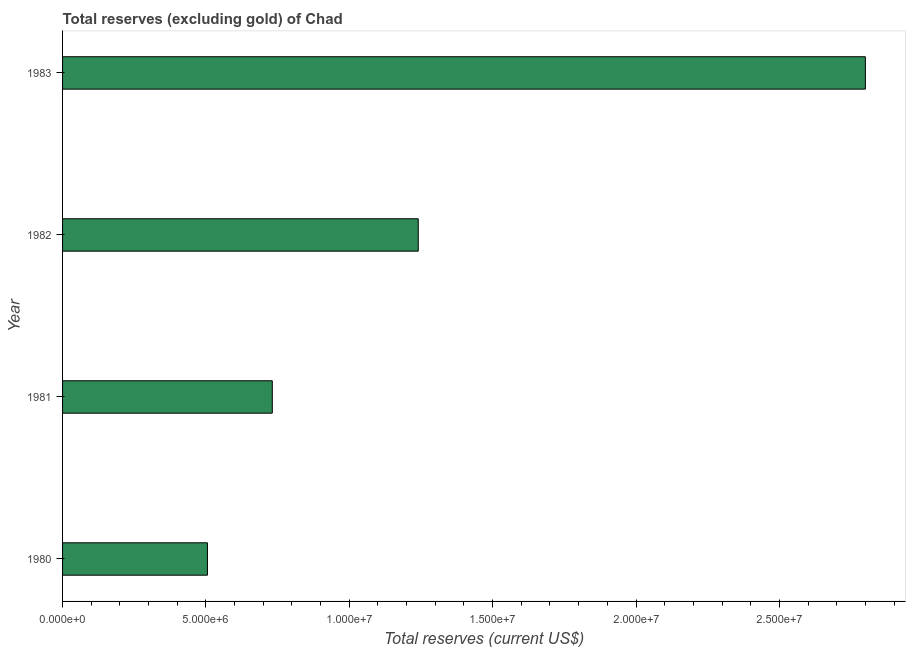Does the graph contain any zero values?
Offer a very short reply. No. What is the title of the graph?
Your response must be concise. Total reserves (excluding gold) of Chad. What is the label or title of the X-axis?
Keep it short and to the point. Total reserves (current US$). What is the label or title of the Y-axis?
Provide a succinct answer. Year. What is the total reserves (excluding gold) in 1983?
Keep it short and to the point. 2.80e+07. Across all years, what is the maximum total reserves (excluding gold)?
Make the answer very short. 2.80e+07. Across all years, what is the minimum total reserves (excluding gold)?
Your answer should be compact. 5.05e+06. What is the sum of the total reserves (excluding gold)?
Offer a terse response. 5.28e+07. What is the difference between the total reserves (excluding gold) in 1980 and 1981?
Provide a short and direct response. -2.26e+06. What is the average total reserves (excluding gold) per year?
Make the answer very short. 1.32e+07. What is the median total reserves (excluding gold)?
Provide a short and direct response. 9.86e+06. Do a majority of the years between 1980 and 1981 (inclusive) have total reserves (excluding gold) greater than 27000000 US$?
Your answer should be very brief. No. What is the ratio of the total reserves (excluding gold) in 1980 to that in 1981?
Give a very brief answer. 0.69. Is the difference between the total reserves (excluding gold) in 1980 and 1982 greater than the difference between any two years?
Ensure brevity in your answer.  No. What is the difference between the highest and the second highest total reserves (excluding gold)?
Give a very brief answer. 1.56e+07. Is the sum of the total reserves (excluding gold) in 1982 and 1983 greater than the maximum total reserves (excluding gold) across all years?
Make the answer very short. Yes. What is the difference between the highest and the lowest total reserves (excluding gold)?
Offer a terse response. 2.29e+07. Are all the bars in the graph horizontal?
Offer a terse response. Yes. What is the difference between two consecutive major ticks on the X-axis?
Give a very brief answer. 5.00e+06. What is the Total reserves (current US$) in 1980?
Give a very brief answer. 5.05e+06. What is the Total reserves (current US$) in 1981?
Ensure brevity in your answer.  7.31e+06. What is the Total reserves (current US$) of 1982?
Offer a terse response. 1.24e+07. What is the Total reserves (current US$) of 1983?
Your response must be concise. 2.80e+07. What is the difference between the Total reserves (current US$) in 1980 and 1981?
Offer a terse response. -2.26e+06. What is the difference between the Total reserves (current US$) in 1980 and 1982?
Make the answer very short. -7.35e+06. What is the difference between the Total reserves (current US$) in 1980 and 1983?
Keep it short and to the point. -2.29e+07. What is the difference between the Total reserves (current US$) in 1981 and 1982?
Provide a succinct answer. -5.09e+06. What is the difference between the Total reserves (current US$) in 1981 and 1983?
Your response must be concise. -2.07e+07. What is the difference between the Total reserves (current US$) in 1982 and 1983?
Keep it short and to the point. -1.56e+07. What is the ratio of the Total reserves (current US$) in 1980 to that in 1981?
Make the answer very short. 0.69. What is the ratio of the Total reserves (current US$) in 1980 to that in 1982?
Make the answer very short. 0.41. What is the ratio of the Total reserves (current US$) in 1980 to that in 1983?
Make the answer very short. 0.18. What is the ratio of the Total reserves (current US$) in 1981 to that in 1982?
Keep it short and to the point. 0.59. What is the ratio of the Total reserves (current US$) in 1981 to that in 1983?
Your response must be concise. 0.26. What is the ratio of the Total reserves (current US$) in 1982 to that in 1983?
Keep it short and to the point. 0.44. 